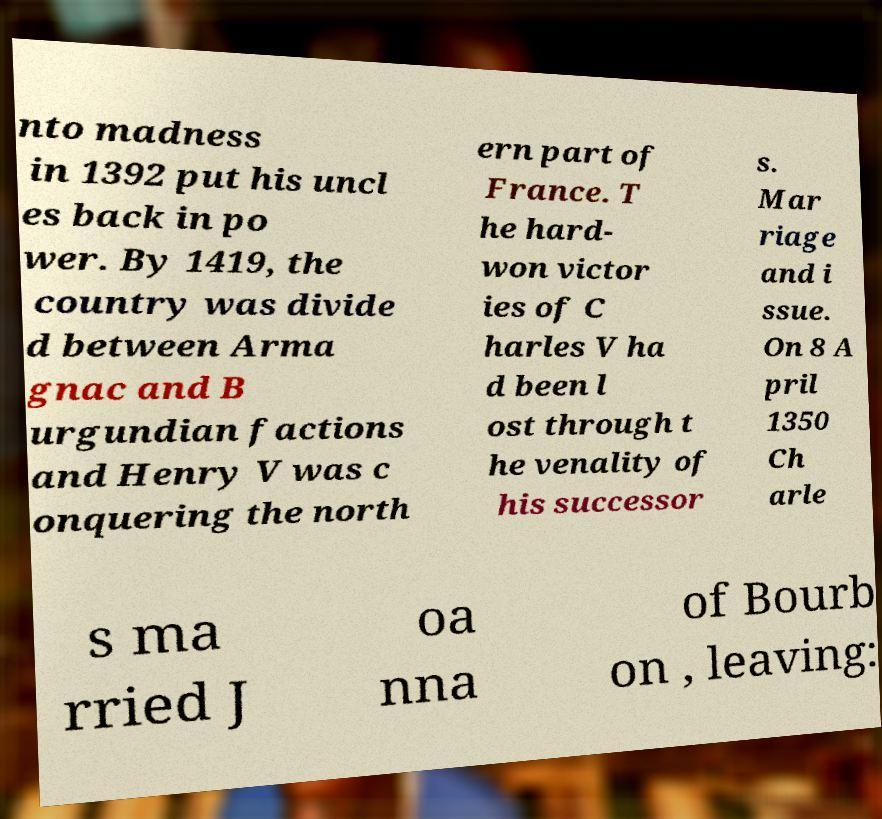Could you assist in decoding the text presented in this image and type it out clearly? nto madness in 1392 put his uncl es back in po wer. By 1419, the country was divide d between Arma gnac and B urgundian factions and Henry V was c onquering the north ern part of France. T he hard- won victor ies of C harles V ha d been l ost through t he venality of his successor s. Mar riage and i ssue. On 8 A pril 1350 Ch arle s ma rried J oa nna of Bourb on , leaving: 